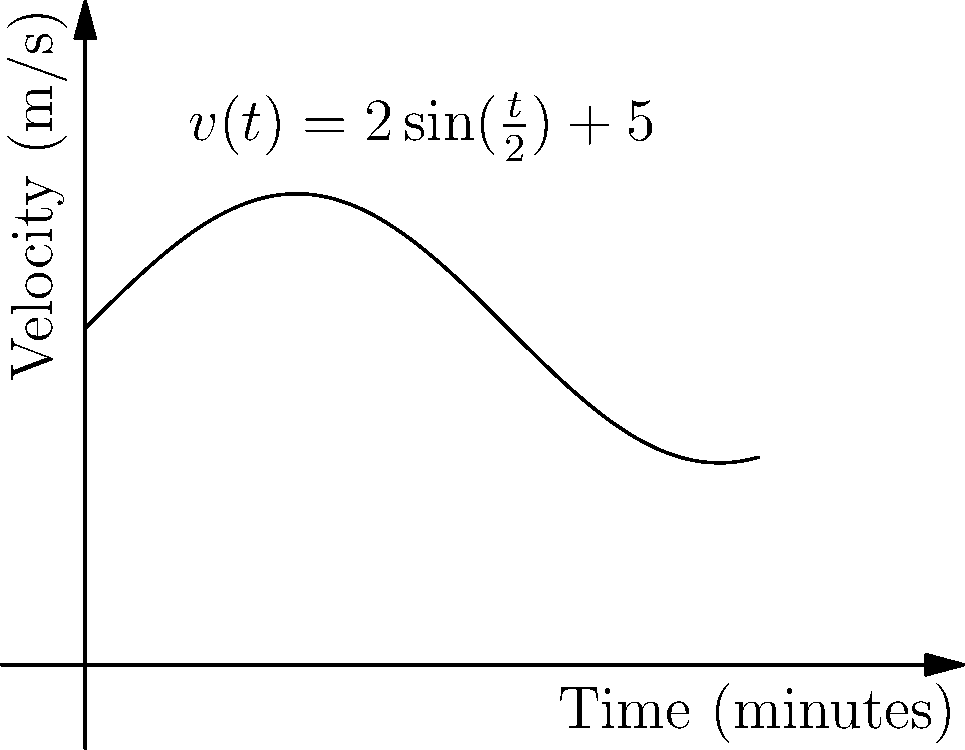Given Messi's velocity-time graph for a 10-minute period during a match, as shown above, where his velocity (in m/s) is described by the function $v(t)=2\sin(\frac{t}{2})+5$, calculate the total distance he covered during this time interval. To find the total distance covered, we need to calculate the area under the velocity-time curve. This can be done using integration.

1) The distance covered is given by the integral of velocity with respect to time:

   $$d = \int_0^{10} v(t) dt$$

2) Substitute the given velocity function:

   $$d = \int_0^{10} (2\sin(\frac{t}{2})+5) dt$$

3) Integrate the function:

   $$d = [-4\cos(\frac{t}{2})+5t]_0^{10}$$

4) Evaluate the integral at the limits:

   $$d = [-4\cos(5)+50] - [-4\cos(0)+0]$$

5) Simplify:

   $$d = -4\cos(5)+50+4$$
   $$d = -4\cos(5)+54$$

6) Calculate the final value (rounded to two decimal places):

   $$d \approx 50.62\text{ meters}$$
Answer: 50.62 meters 